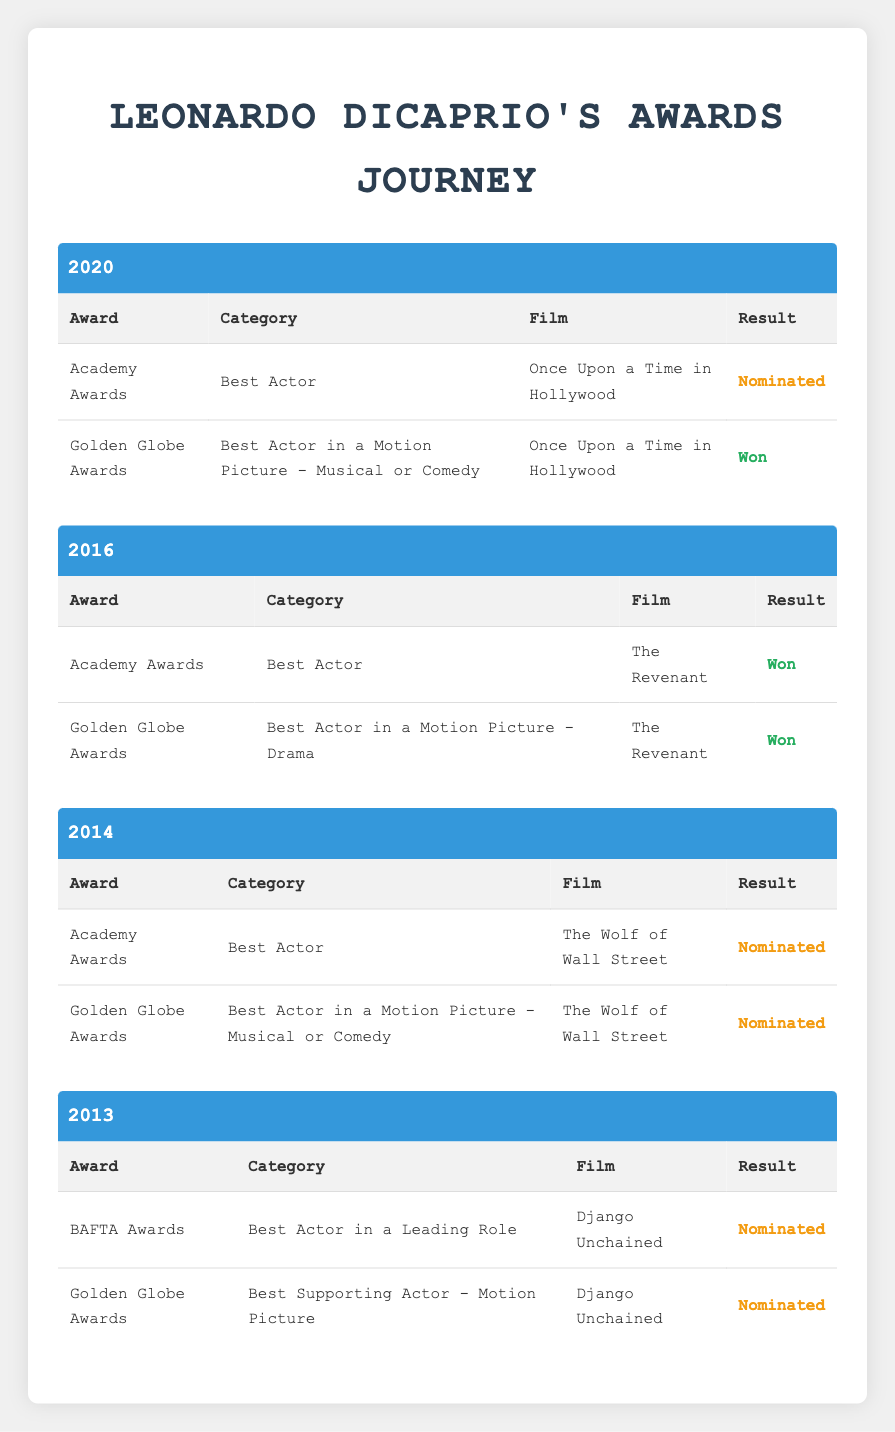What award did Leonardo DiCaprio win in 2016? In 2016, Leonardo DiCaprio won the Academy Award in the Best Actor category for the film "The Revenant."
Answer: Academy Award for Best Actor How many nominations did Leonardo DiCaprio receive in 2020? In 2020, Leonardo DiCaprio received two nominations for "Once Upon a Time in Hollywood": one from the Academy Awards and one from the Golden Globe Awards.
Answer: Two nominations Did Leonardo DiCaprio win any awards in 2014? In 2014, Leonardo DiCaprio was nominated for two awards for "The Wolf of Wall Street," but he did not win either. Therefore, he did not win any awards that year.
Answer: No What is the total number of awards won by Leonardo DiCaprio from 2013 to 2016? From 2013 to 2016, Leonardo DiCaprio won a total of three awards: two from the Golden Globes (2016) and one from the Academy Awards (2016). There were no wins in 2013 and 2014.
Answer: Three awards Which film earned Leonardo DiCaprio a Golden Globe Award in 2016? The film "The Revenant" earned Leonardo DiCaprio a Golden Globe Award in the Best Actor in a Motion Picture - Drama category in 2016.
Answer: The Revenant How many awards did Leonardo DiCaprio receive nominations for in 2013? In 2013, Leonardo DiCaprio received nominations for two awards: one from the BAFTA Awards and one from the Golden Globe Awards for the film "Django Unchained."
Answer: Two nominations Was Leonardo DiCaprio nominated for the Academy Awards in 2014? Yes, Leonardo DiCaprio was nominated for the Academy Awards for Best Actor for "The Wolf of Wall Street" in 2014.
Answer: Yes In which year did Leonardo DiCaprio achieve his first Academy Award win? Leonardo DiCaprio achieved his first Academy Award win in 2016 for his role in "The Revenant."
Answer: 2016 